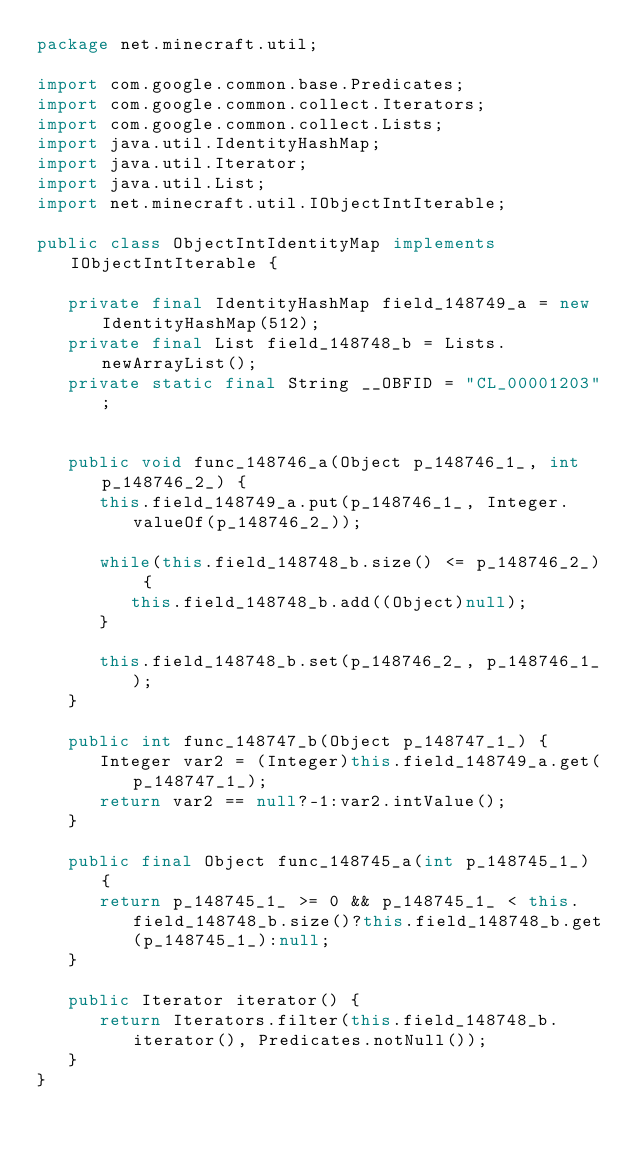Convert code to text. <code><loc_0><loc_0><loc_500><loc_500><_Java_>package net.minecraft.util;

import com.google.common.base.Predicates;
import com.google.common.collect.Iterators;
import com.google.common.collect.Lists;
import java.util.IdentityHashMap;
import java.util.Iterator;
import java.util.List;
import net.minecraft.util.IObjectIntIterable;

public class ObjectIntIdentityMap implements IObjectIntIterable {

   private final IdentityHashMap field_148749_a = new IdentityHashMap(512);
   private final List field_148748_b = Lists.newArrayList();
   private static final String __OBFID = "CL_00001203";


   public void func_148746_a(Object p_148746_1_, int p_148746_2_) {
      this.field_148749_a.put(p_148746_1_, Integer.valueOf(p_148746_2_));

      while(this.field_148748_b.size() <= p_148746_2_) {
         this.field_148748_b.add((Object)null);
      }

      this.field_148748_b.set(p_148746_2_, p_148746_1_);
   }

   public int func_148747_b(Object p_148747_1_) {
      Integer var2 = (Integer)this.field_148749_a.get(p_148747_1_);
      return var2 == null?-1:var2.intValue();
   }

   public final Object func_148745_a(int p_148745_1_) {
      return p_148745_1_ >= 0 && p_148745_1_ < this.field_148748_b.size()?this.field_148748_b.get(p_148745_1_):null;
   }

   public Iterator iterator() {
      return Iterators.filter(this.field_148748_b.iterator(), Predicates.notNull());
   }
}
</code> 